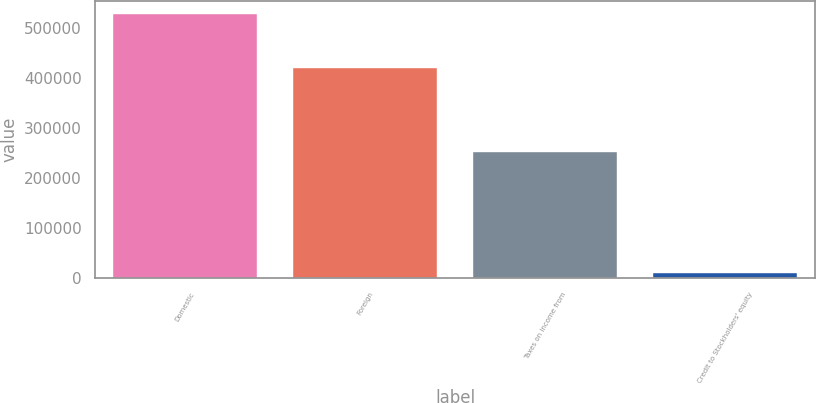Convert chart. <chart><loc_0><loc_0><loc_500><loc_500><bar_chart><fcel>Domestic<fcel>Foreign<fcel>Taxes on income from<fcel>Credit to Stockholders' equity<nl><fcel>527509<fcel>418510<fcel>251261<fcel>8449<nl></chart> 